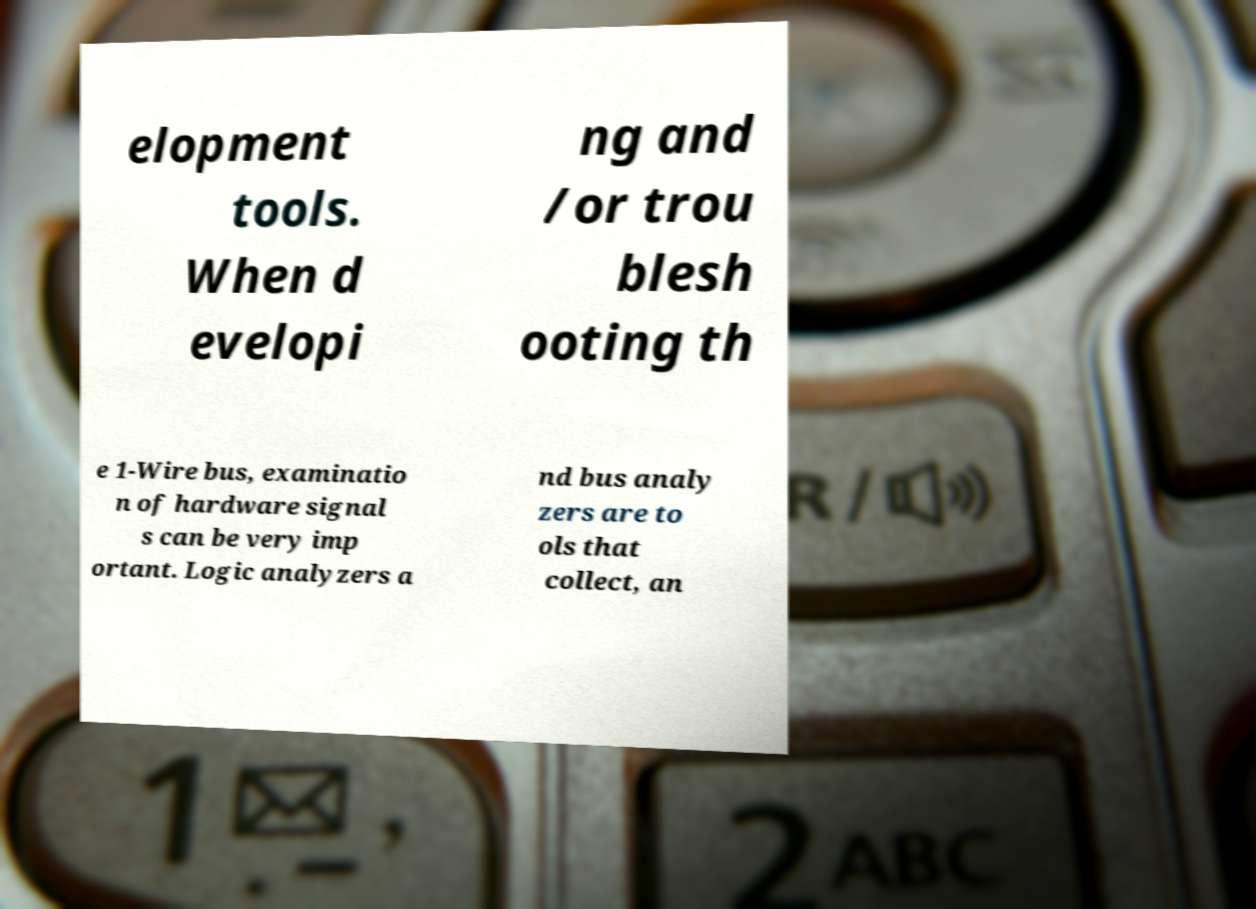What messages or text are displayed in this image? I need them in a readable, typed format. elopment tools. When d evelopi ng and /or trou blesh ooting th e 1-Wire bus, examinatio n of hardware signal s can be very imp ortant. Logic analyzers a nd bus analy zers are to ols that collect, an 